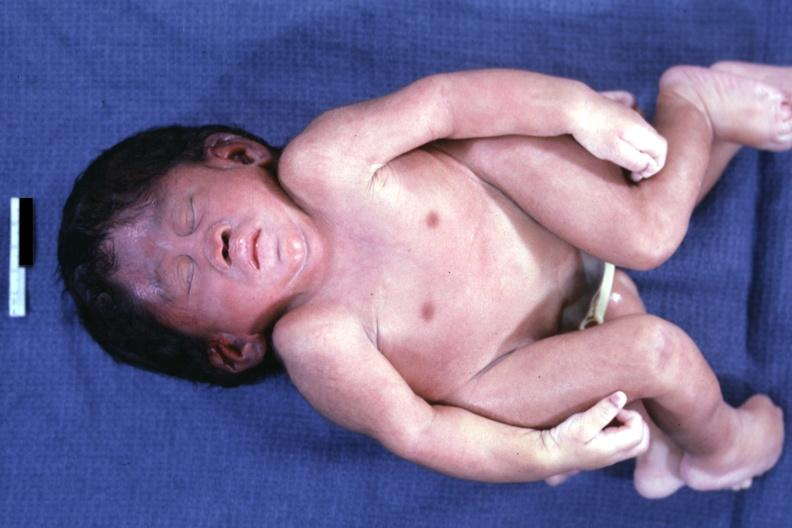what is present?
Answer the question using a single word or phrase. Conjoined twins cephalothoracopagus janiceps 